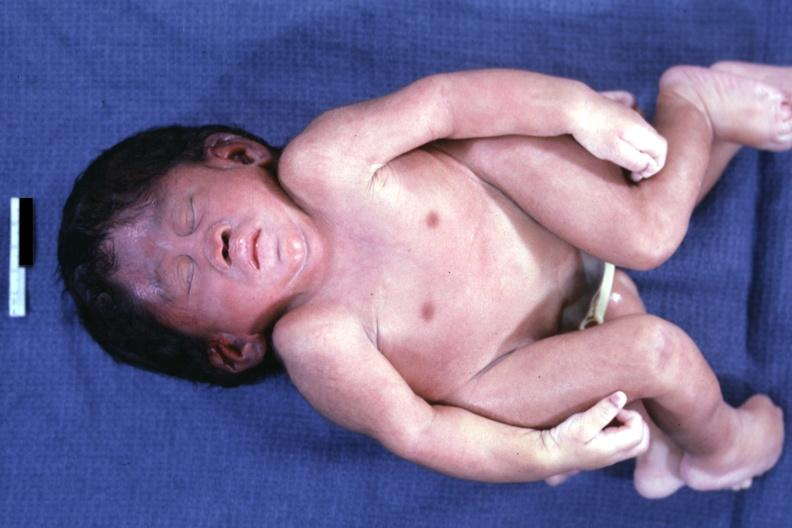what is present?
Answer the question using a single word or phrase. Conjoined twins cephalothoracopagus janiceps 